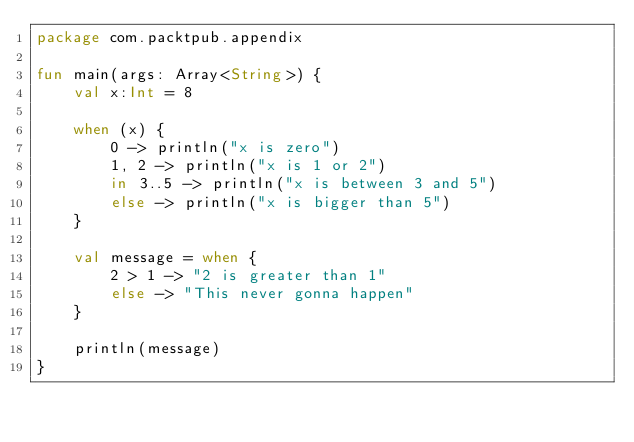<code> <loc_0><loc_0><loc_500><loc_500><_Kotlin_>package com.packtpub.appendix

fun main(args: Array<String>) {
    val x:Int = 8

    when (x) {
        0 -> println("x is zero")
        1, 2 -> println("x is 1 or 2")
        in 3..5 -> println("x is between 3 and 5")
        else -> println("x is bigger than 5")
    }

    val message = when {
        2 > 1 -> "2 is greater than 1"
        else -> "This never gonna happen"
    }

    println(message)
}</code> 